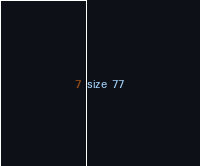<code> <loc_0><loc_0><loc_500><loc_500><_YAML_>size 77
</code> 